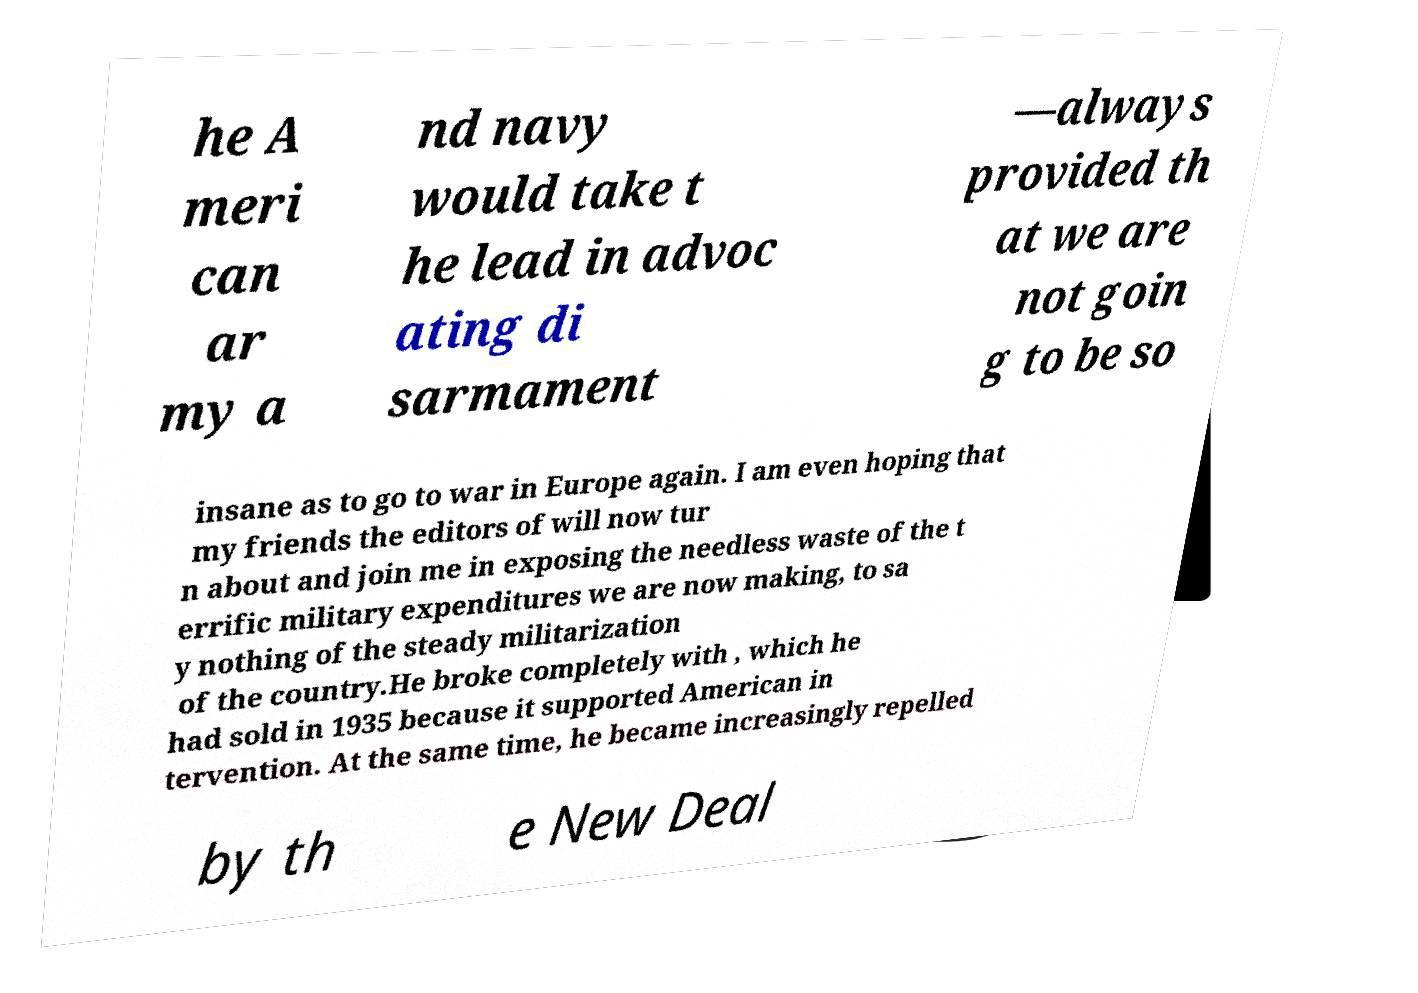Please identify and transcribe the text found in this image. he A meri can ar my a nd navy would take t he lead in advoc ating di sarmament —always provided th at we are not goin g to be so insane as to go to war in Europe again. I am even hoping that my friends the editors of will now tur n about and join me in exposing the needless waste of the t errific military expenditures we are now making, to sa y nothing of the steady militarization of the country.He broke completely with , which he had sold in 1935 because it supported American in tervention. At the same time, he became increasingly repelled by th e New Deal 